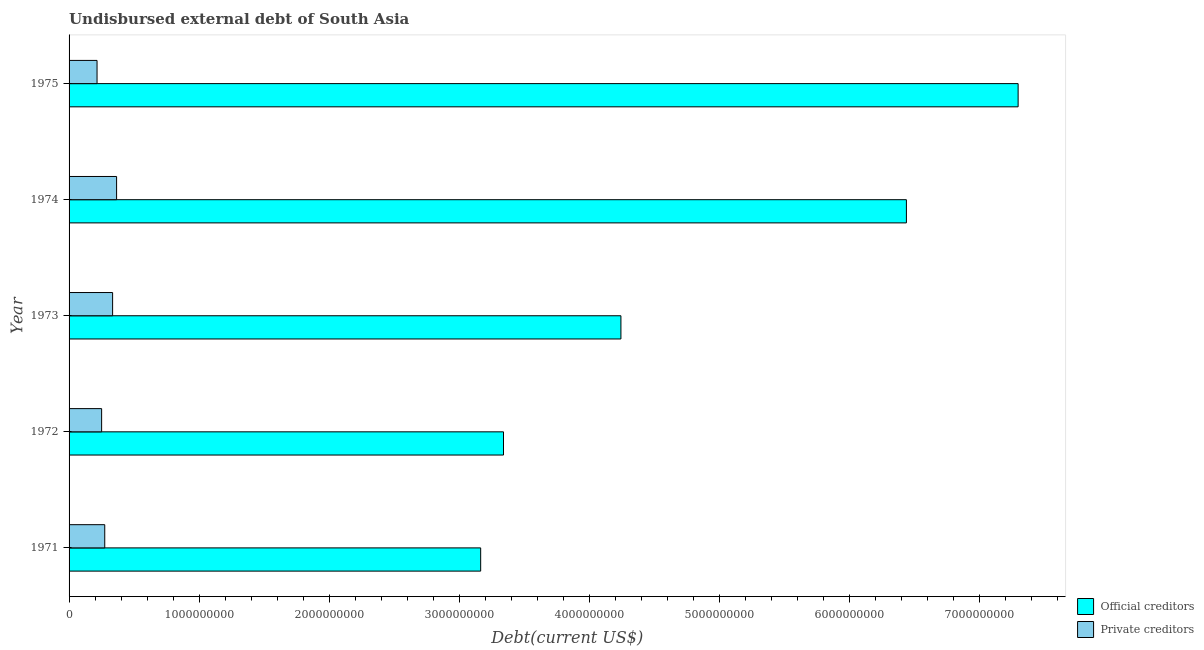How many different coloured bars are there?
Your answer should be very brief. 2. How many groups of bars are there?
Ensure brevity in your answer.  5. Are the number of bars per tick equal to the number of legend labels?
Provide a short and direct response. Yes. How many bars are there on the 1st tick from the bottom?
Offer a terse response. 2. What is the label of the 1st group of bars from the top?
Keep it short and to the point. 1975. In how many cases, is the number of bars for a given year not equal to the number of legend labels?
Your answer should be very brief. 0. What is the undisbursed external debt of private creditors in 1971?
Provide a short and direct response. 2.74e+08. Across all years, what is the maximum undisbursed external debt of official creditors?
Keep it short and to the point. 7.30e+09. Across all years, what is the minimum undisbursed external debt of official creditors?
Offer a terse response. 3.16e+09. In which year was the undisbursed external debt of private creditors maximum?
Provide a succinct answer. 1974. In which year was the undisbursed external debt of private creditors minimum?
Provide a succinct answer. 1975. What is the total undisbursed external debt of official creditors in the graph?
Make the answer very short. 2.45e+1. What is the difference between the undisbursed external debt of private creditors in 1972 and that in 1975?
Ensure brevity in your answer.  3.51e+07. What is the difference between the undisbursed external debt of private creditors in 1972 and the undisbursed external debt of official creditors in 1973?
Ensure brevity in your answer.  -3.99e+09. What is the average undisbursed external debt of official creditors per year?
Your answer should be compact. 4.90e+09. In the year 1971, what is the difference between the undisbursed external debt of official creditors and undisbursed external debt of private creditors?
Give a very brief answer. 2.89e+09. In how many years, is the undisbursed external debt of official creditors greater than 6800000000 US$?
Provide a short and direct response. 1. What is the ratio of the undisbursed external debt of private creditors in 1971 to that in 1975?
Make the answer very short. 1.27. Is the undisbursed external debt of official creditors in 1971 less than that in 1975?
Provide a short and direct response. Yes. Is the difference between the undisbursed external debt of private creditors in 1974 and 1975 greater than the difference between the undisbursed external debt of official creditors in 1974 and 1975?
Your answer should be compact. Yes. What is the difference between the highest and the second highest undisbursed external debt of private creditors?
Your response must be concise. 3.06e+07. What is the difference between the highest and the lowest undisbursed external debt of official creditors?
Give a very brief answer. 4.13e+09. In how many years, is the undisbursed external debt of private creditors greater than the average undisbursed external debt of private creditors taken over all years?
Your response must be concise. 2. What does the 2nd bar from the top in 1973 represents?
Your answer should be compact. Official creditors. What does the 1st bar from the bottom in 1974 represents?
Offer a terse response. Official creditors. How many bars are there?
Make the answer very short. 10. Are all the bars in the graph horizontal?
Offer a terse response. Yes. Does the graph contain any zero values?
Ensure brevity in your answer.  No. Does the graph contain grids?
Provide a short and direct response. No. Where does the legend appear in the graph?
Your answer should be very brief. Bottom right. How are the legend labels stacked?
Provide a short and direct response. Vertical. What is the title of the graph?
Give a very brief answer. Undisbursed external debt of South Asia. Does "Education" appear as one of the legend labels in the graph?
Make the answer very short. No. What is the label or title of the X-axis?
Offer a very short reply. Debt(current US$). What is the Debt(current US$) of Official creditors in 1971?
Keep it short and to the point. 3.16e+09. What is the Debt(current US$) in Private creditors in 1971?
Provide a short and direct response. 2.74e+08. What is the Debt(current US$) in Official creditors in 1972?
Provide a short and direct response. 3.34e+09. What is the Debt(current US$) in Private creditors in 1972?
Your answer should be very brief. 2.50e+08. What is the Debt(current US$) in Official creditors in 1973?
Your response must be concise. 4.24e+09. What is the Debt(current US$) in Private creditors in 1973?
Offer a very short reply. 3.35e+08. What is the Debt(current US$) of Official creditors in 1974?
Make the answer very short. 6.44e+09. What is the Debt(current US$) of Private creditors in 1974?
Your response must be concise. 3.65e+08. What is the Debt(current US$) in Official creditors in 1975?
Offer a terse response. 7.30e+09. What is the Debt(current US$) in Private creditors in 1975?
Provide a succinct answer. 2.15e+08. Across all years, what is the maximum Debt(current US$) of Official creditors?
Give a very brief answer. 7.30e+09. Across all years, what is the maximum Debt(current US$) of Private creditors?
Your answer should be very brief. 3.65e+08. Across all years, what is the minimum Debt(current US$) in Official creditors?
Ensure brevity in your answer.  3.16e+09. Across all years, what is the minimum Debt(current US$) of Private creditors?
Your response must be concise. 2.15e+08. What is the total Debt(current US$) in Official creditors in the graph?
Offer a terse response. 2.45e+1. What is the total Debt(current US$) of Private creditors in the graph?
Offer a very short reply. 1.44e+09. What is the difference between the Debt(current US$) in Official creditors in 1971 and that in 1972?
Ensure brevity in your answer.  -1.76e+08. What is the difference between the Debt(current US$) in Private creditors in 1971 and that in 1972?
Ensure brevity in your answer.  2.41e+07. What is the difference between the Debt(current US$) of Official creditors in 1971 and that in 1973?
Your response must be concise. -1.08e+09. What is the difference between the Debt(current US$) in Private creditors in 1971 and that in 1973?
Make the answer very short. -6.04e+07. What is the difference between the Debt(current US$) of Official creditors in 1971 and that in 1974?
Your answer should be very brief. -3.27e+09. What is the difference between the Debt(current US$) of Private creditors in 1971 and that in 1974?
Your response must be concise. -9.10e+07. What is the difference between the Debt(current US$) in Official creditors in 1971 and that in 1975?
Offer a very short reply. -4.13e+09. What is the difference between the Debt(current US$) of Private creditors in 1971 and that in 1975?
Your response must be concise. 5.92e+07. What is the difference between the Debt(current US$) of Official creditors in 1972 and that in 1973?
Provide a short and direct response. -9.03e+08. What is the difference between the Debt(current US$) in Private creditors in 1972 and that in 1973?
Your answer should be compact. -8.45e+07. What is the difference between the Debt(current US$) of Official creditors in 1972 and that in 1974?
Offer a terse response. -3.10e+09. What is the difference between the Debt(current US$) in Private creditors in 1972 and that in 1974?
Your answer should be compact. -1.15e+08. What is the difference between the Debt(current US$) of Official creditors in 1972 and that in 1975?
Keep it short and to the point. -3.96e+09. What is the difference between the Debt(current US$) in Private creditors in 1972 and that in 1975?
Provide a succinct answer. 3.51e+07. What is the difference between the Debt(current US$) in Official creditors in 1973 and that in 1974?
Offer a terse response. -2.20e+09. What is the difference between the Debt(current US$) of Private creditors in 1973 and that in 1974?
Offer a very short reply. -3.06e+07. What is the difference between the Debt(current US$) in Official creditors in 1973 and that in 1975?
Your answer should be very brief. -3.05e+09. What is the difference between the Debt(current US$) of Private creditors in 1973 and that in 1975?
Your answer should be very brief. 1.20e+08. What is the difference between the Debt(current US$) of Official creditors in 1974 and that in 1975?
Offer a terse response. -8.59e+08. What is the difference between the Debt(current US$) of Private creditors in 1974 and that in 1975?
Your response must be concise. 1.50e+08. What is the difference between the Debt(current US$) of Official creditors in 1971 and the Debt(current US$) of Private creditors in 1972?
Give a very brief answer. 2.91e+09. What is the difference between the Debt(current US$) of Official creditors in 1971 and the Debt(current US$) of Private creditors in 1973?
Give a very brief answer. 2.83e+09. What is the difference between the Debt(current US$) in Official creditors in 1971 and the Debt(current US$) in Private creditors in 1974?
Provide a succinct answer. 2.80e+09. What is the difference between the Debt(current US$) of Official creditors in 1971 and the Debt(current US$) of Private creditors in 1975?
Keep it short and to the point. 2.95e+09. What is the difference between the Debt(current US$) of Official creditors in 1972 and the Debt(current US$) of Private creditors in 1973?
Offer a terse response. 3.01e+09. What is the difference between the Debt(current US$) of Official creditors in 1972 and the Debt(current US$) of Private creditors in 1974?
Offer a terse response. 2.97e+09. What is the difference between the Debt(current US$) of Official creditors in 1972 and the Debt(current US$) of Private creditors in 1975?
Your response must be concise. 3.13e+09. What is the difference between the Debt(current US$) of Official creditors in 1973 and the Debt(current US$) of Private creditors in 1974?
Offer a terse response. 3.88e+09. What is the difference between the Debt(current US$) in Official creditors in 1973 and the Debt(current US$) in Private creditors in 1975?
Offer a very short reply. 4.03e+09. What is the difference between the Debt(current US$) of Official creditors in 1974 and the Debt(current US$) of Private creditors in 1975?
Offer a very short reply. 6.22e+09. What is the average Debt(current US$) in Official creditors per year?
Your answer should be compact. 4.90e+09. What is the average Debt(current US$) of Private creditors per year?
Keep it short and to the point. 2.88e+08. In the year 1971, what is the difference between the Debt(current US$) in Official creditors and Debt(current US$) in Private creditors?
Your answer should be very brief. 2.89e+09. In the year 1972, what is the difference between the Debt(current US$) in Official creditors and Debt(current US$) in Private creditors?
Provide a succinct answer. 3.09e+09. In the year 1973, what is the difference between the Debt(current US$) in Official creditors and Debt(current US$) in Private creditors?
Give a very brief answer. 3.91e+09. In the year 1974, what is the difference between the Debt(current US$) of Official creditors and Debt(current US$) of Private creditors?
Offer a terse response. 6.07e+09. In the year 1975, what is the difference between the Debt(current US$) of Official creditors and Debt(current US$) of Private creditors?
Provide a succinct answer. 7.08e+09. What is the ratio of the Debt(current US$) in Official creditors in 1971 to that in 1972?
Make the answer very short. 0.95. What is the ratio of the Debt(current US$) of Private creditors in 1971 to that in 1972?
Ensure brevity in your answer.  1.1. What is the ratio of the Debt(current US$) in Official creditors in 1971 to that in 1973?
Ensure brevity in your answer.  0.75. What is the ratio of the Debt(current US$) in Private creditors in 1971 to that in 1973?
Offer a very short reply. 0.82. What is the ratio of the Debt(current US$) of Official creditors in 1971 to that in 1974?
Offer a very short reply. 0.49. What is the ratio of the Debt(current US$) of Private creditors in 1971 to that in 1974?
Ensure brevity in your answer.  0.75. What is the ratio of the Debt(current US$) of Official creditors in 1971 to that in 1975?
Your response must be concise. 0.43. What is the ratio of the Debt(current US$) of Private creditors in 1971 to that in 1975?
Your answer should be very brief. 1.28. What is the ratio of the Debt(current US$) in Official creditors in 1972 to that in 1973?
Make the answer very short. 0.79. What is the ratio of the Debt(current US$) of Private creditors in 1972 to that in 1973?
Offer a very short reply. 0.75. What is the ratio of the Debt(current US$) in Official creditors in 1972 to that in 1974?
Your answer should be very brief. 0.52. What is the ratio of the Debt(current US$) in Private creditors in 1972 to that in 1974?
Provide a short and direct response. 0.68. What is the ratio of the Debt(current US$) of Official creditors in 1972 to that in 1975?
Your response must be concise. 0.46. What is the ratio of the Debt(current US$) of Private creditors in 1972 to that in 1975?
Your response must be concise. 1.16. What is the ratio of the Debt(current US$) in Official creditors in 1973 to that in 1974?
Ensure brevity in your answer.  0.66. What is the ratio of the Debt(current US$) in Private creditors in 1973 to that in 1974?
Make the answer very short. 0.92. What is the ratio of the Debt(current US$) in Official creditors in 1973 to that in 1975?
Keep it short and to the point. 0.58. What is the ratio of the Debt(current US$) of Private creditors in 1973 to that in 1975?
Provide a short and direct response. 1.56. What is the ratio of the Debt(current US$) of Official creditors in 1974 to that in 1975?
Your answer should be very brief. 0.88. What is the ratio of the Debt(current US$) in Private creditors in 1974 to that in 1975?
Provide a succinct answer. 1.7. What is the difference between the highest and the second highest Debt(current US$) of Official creditors?
Give a very brief answer. 8.59e+08. What is the difference between the highest and the second highest Debt(current US$) in Private creditors?
Offer a very short reply. 3.06e+07. What is the difference between the highest and the lowest Debt(current US$) of Official creditors?
Your answer should be very brief. 4.13e+09. What is the difference between the highest and the lowest Debt(current US$) of Private creditors?
Offer a terse response. 1.50e+08. 